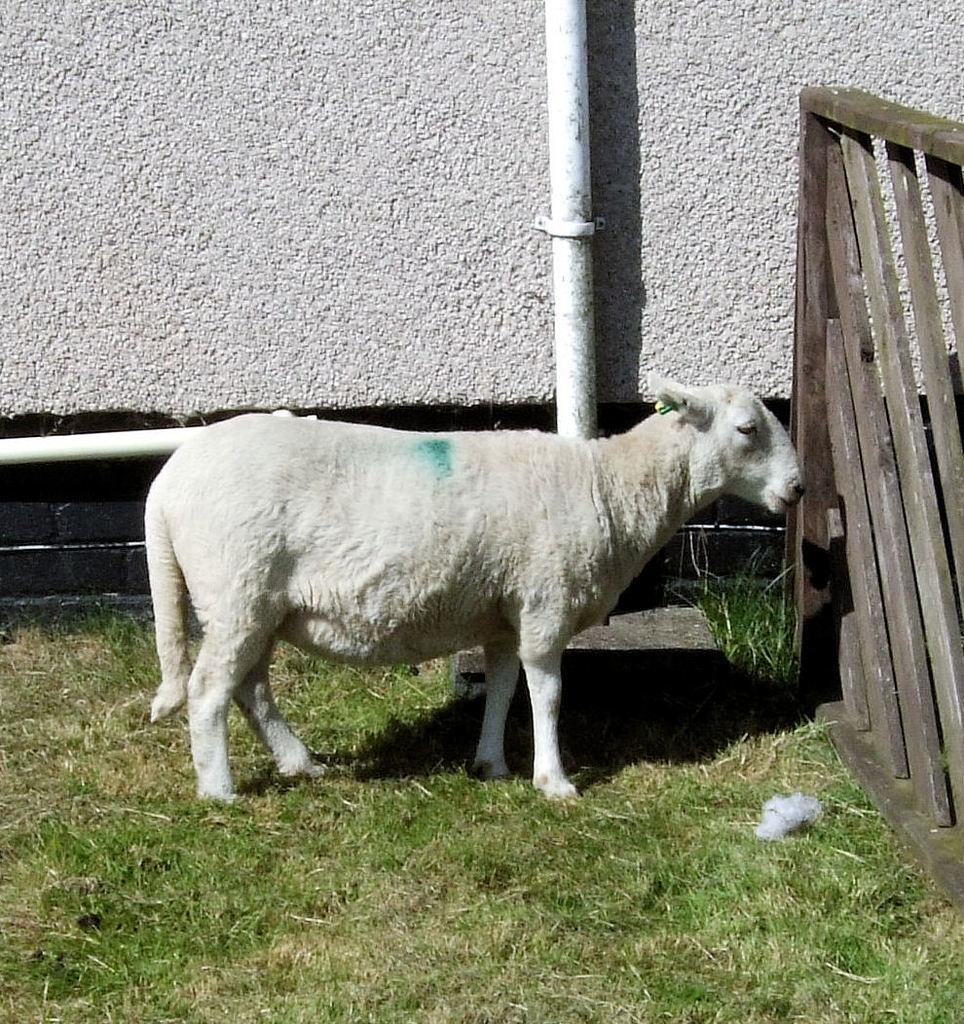What animal is in the foreground of the image? There is a white sheep in the foreground of the image. What is the sheep standing on? The sheep is on the grass. What can be seen on the right side of the image? There is a wooden fencing on the right side of the image. What structures are visible at the top of the image? There is a wall and a pipe on the top of the image. What language is the sheep speaking in the image? Sheep do not speak any language, so this cannot be determined from the image. 